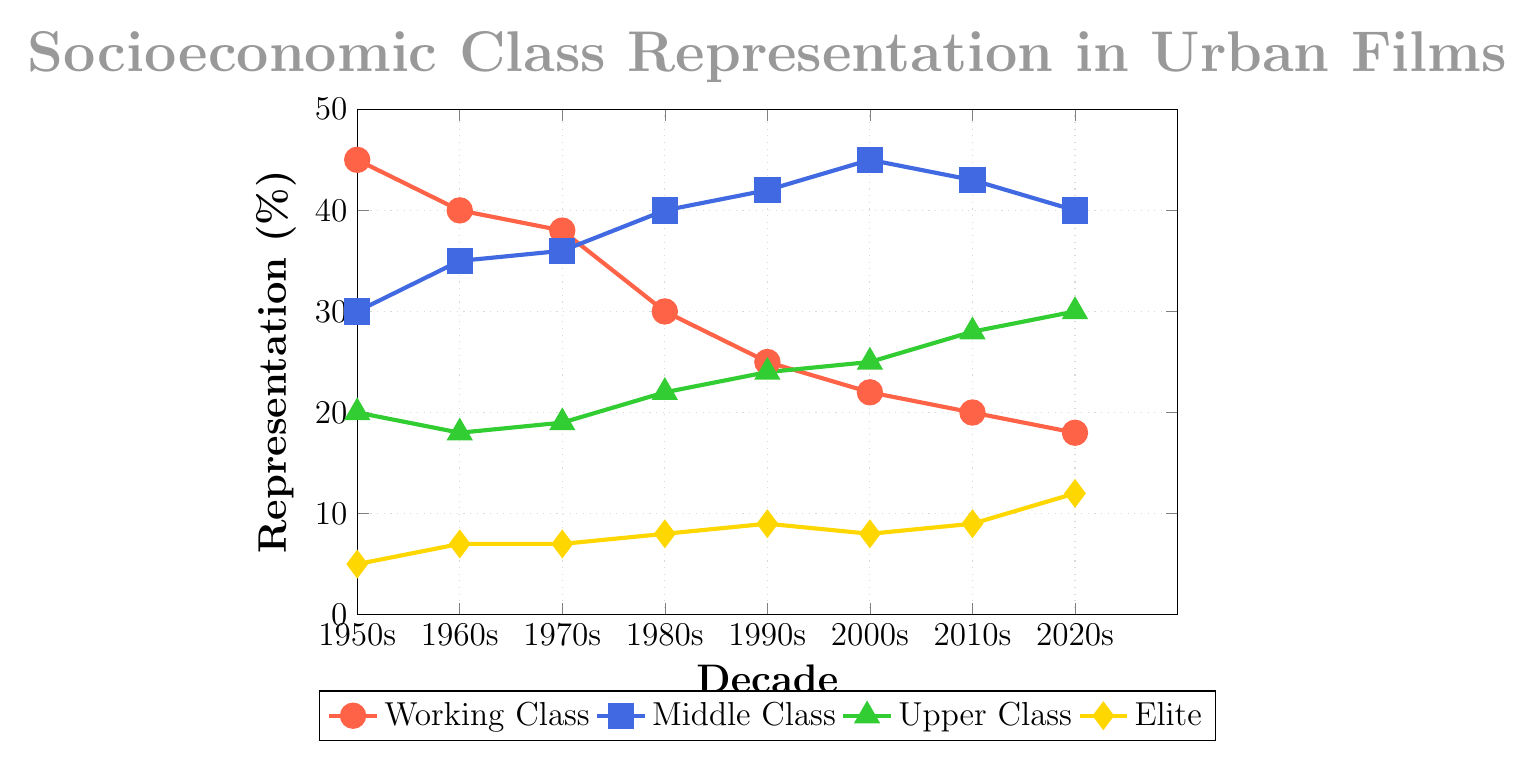what decade saw the highest representation of the working class, and what was the percentage? The highest representation of the working class occurred in the 1950s, which can be determined by looking at the peak of the red line representing the working class category. The percentage at this peak is 45%.
Answer: 1950s, 45% Compare the representation of the middle class in the 1980s and the 2020s. To compare, look at the height of the blue line representing the middle class in both decades. In the 1980s, the representation is 40%, and in the 2020s, it is also 40%, indicating no change.
Answer: Both are 40% What is the trend in the representation of the elite class from the 1950s to the 2020s? Observe the diamond marks representing the elite class across decades. The trend shows a gradual increase from 5% in the 1950s to 12% in the 2020s.
Answer: Increasing trend Which class has the lowest variation in representation over the decades? Determine the variation by evaluating the difference between the highest and lowest percentages for each class. The elite class has the smallest range, from 5% to 12%, a difference of 7%.
Answer: Elite class What is the sum of the representation percentages of the upper class and elite class in the 2010s? Add the percentages of the green line for the upper class (28%) and the yellow line for the elite class (9%) in the 2010s. The sum is 28% + 9% = 37%.
Answer: 37% Identify the decade with the smallest representation of the upper class and specify the percentage. Locate the smallest point on the green line representing the upper class, which is in the 1960s at 18%.
Answer: 1960s, 18% What is the average representation of the working class across all decades? Sum the working-class percentages for all decades: 45+40+38+30+25+22+20+18 = 238. Divide by the number of decades (8): 238/8 = 29.75%
Answer: 29.75% How does the representation of the working class in the 1960s compare to the middle class in the 1950s? The red line for the working class in the 1960s is at 40%, while the blue line for the middle class in the 1950s is at 30%. The working class in the 1960s is higher by 10%.
Answer: Working class is higher by 10% By how much did the representation of the middle class increase from the 1950s to the 2000s? Determine the difference between the middle class percentages in these decades: 45% (2000s) - 30% (1950s) = 15%.
Answer: Increased by 15% 